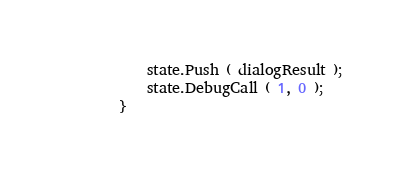Convert code to text. <code><loc_0><loc_0><loc_500><loc_500><_ObjectiveC_>			state.Push ( dialogResult );
			state.DebugCall ( 1, 0 );
		}
		</code> 